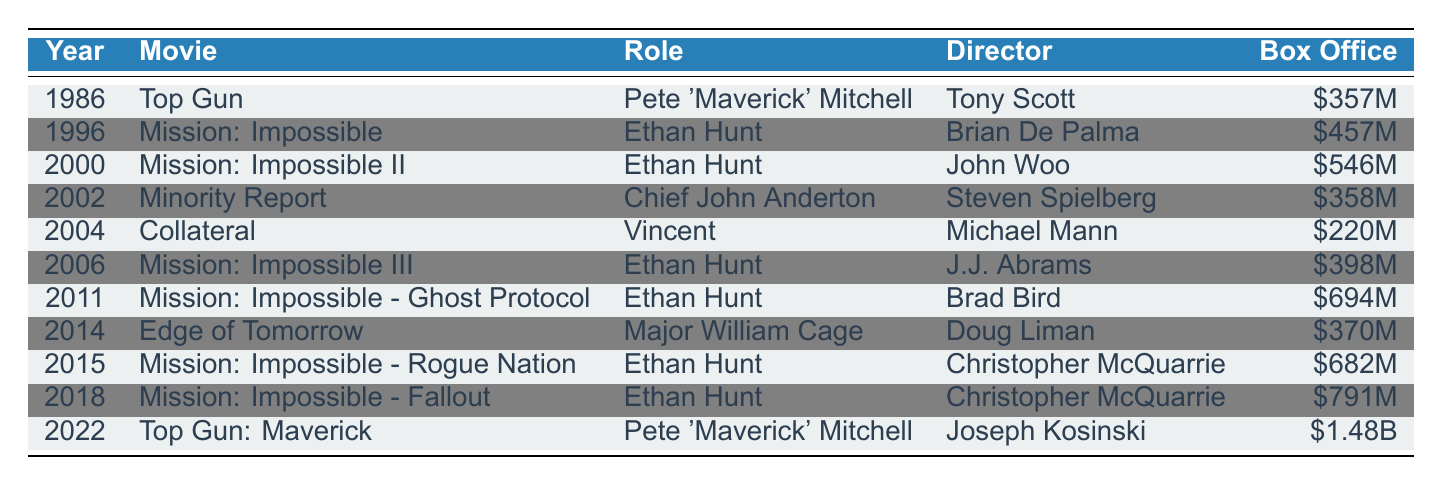What was Tom Cruise's first action movie? The first action movie in the timeline is "Top Gun," released in 1986.
Answer: Top Gun Which movie grossed the highest box office revenue? The highest box office gross is from "Top Gun: Maverick," which made $1.48 billion in 2022.
Answer: Top Gun: Maverick How many movies did Tom Cruise release in the 2000s? Tom Cruise released four movies in the timeline during the 2000s: "Mission: Impossible II" (2000), "Minority Report" (2002), "Collateral" (2004), and "Mission: Impossible III" (2006).
Answer: Four What role did Tom Cruise play in the movie released in 2014? In 2014, Tom Cruise played Major William Cage in the movie "Edge of Tomorrow."
Answer: Major William Cage Was Tom Cruise's character in "Mission: Impossible III" the same as in earlier films? Yes, Tom Cruise played Ethan Hunt in "Mission: Impossible III," which is the same role he had in earlier films, specifically in "Mission: Impossible" (1996) and "Mission: Impossible II" (2000).
Answer: Yes Calculate the total box office gross for all movies where he played Ethan Hunt. The box office gross for the movies with Ethan Hunt are as follows: Mission: Impossible ($457M) + Mission: Impossible II ($546M) + Mission: Impossible III ($398M) + Mission: Impossible - Ghost Protocol ($694M) + Mission: Impossible - Rogue Nation ($682M) + Mission: Impossible - Fallout ($791M). The total is $457M + $546M + $398M + $694M + $682M + $791M = $3.568 billion.
Answer: $3.568 billion Which director worked on the most movies featuring Tom Cruise in this timeline? Christopher McQuarrie directed three films: "Mission: Impossible - Rogue Nation" (2015), "Mission: Impossible - Fallout" (2018), and "Mission: Impossible - Ghost Protocol" (2011).
Answer: Christopher McQuarrie In what year did Tom Cruise last play the role of Pete 'Maverick' Mitchell? Tom Cruise last played Pete 'Maverick' Mitchell in "Top Gun: Maverick," which was released in 2022.
Answer: 2022 